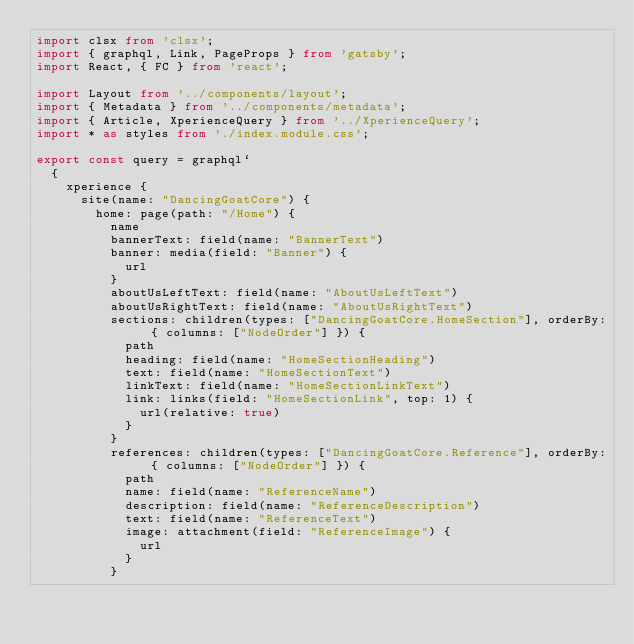Convert code to text. <code><loc_0><loc_0><loc_500><loc_500><_TypeScript_>import clsx from 'clsx';
import { graphql, Link, PageProps } from 'gatsby';
import React, { FC } from 'react';

import Layout from '../components/layout';
import { Metadata } from '../components/metadata';
import { Article, XperienceQuery } from '../XperienceQuery';
import * as styles from './index.module.css';

export const query = graphql`
  {
    xperience {
      site(name: "DancingGoatCore") {
        home: page(path: "/Home") {
          name
          bannerText: field(name: "BannerText")
          banner: media(field: "Banner") {
            url
          }
          aboutUsLeftText: field(name: "AboutUsLeftText")
          aboutUsRightText: field(name: "AboutUsRightText")
          sections: children(types: ["DancingGoatCore.HomeSection"], orderBy: { columns: ["NodeOrder"] }) {
            path
            heading: field(name: "HomeSectionHeading")
            text: field(name: "HomeSectionText")
            linkText: field(name: "HomeSectionLinkText")
            link: links(field: "HomeSectionLink", top: 1) {
              url(relative: true)
            }
          }
          references: children(types: ["DancingGoatCore.Reference"], orderBy: { columns: ["NodeOrder"] }) {
            path
            name: field(name: "ReferenceName")
            description: field(name: "ReferenceDescription")
            text: field(name: "ReferenceText")
            image: attachment(field: "ReferenceImage") {
              url
            }
          }</code> 